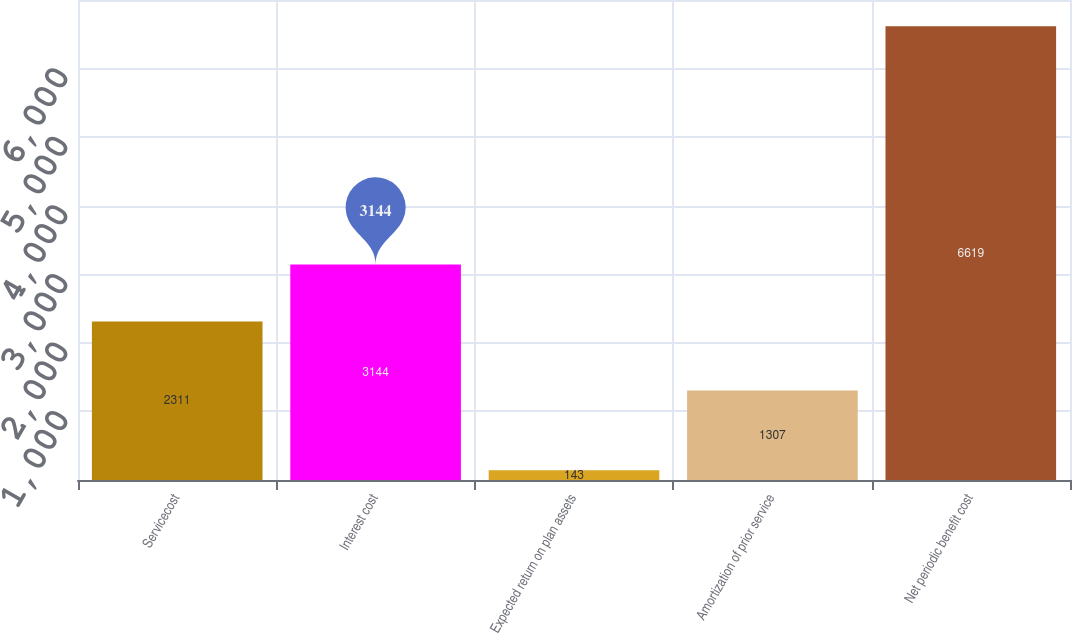<chart> <loc_0><loc_0><loc_500><loc_500><bar_chart><fcel>Servicecost<fcel>Interest cost<fcel>Expected return on plan assets<fcel>Amortization of prior service<fcel>Net periodic benefit cost<nl><fcel>2311<fcel>3144<fcel>143<fcel>1307<fcel>6619<nl></chart> 